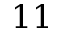<formula> <loc_0><loc_0><loc_500><loc_500>1 1</formula> 